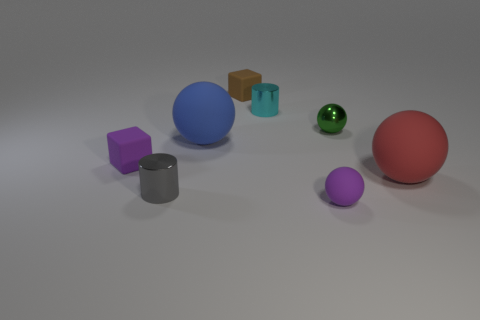Subtract all gray spheres. Subtract all brown cylinders. How many spheres are left? 4 Add 2 tiny green balls. How many objects exist? 10 Subtract all cubes. How many objects are left? 6 Subtract all red objects. Subtract all green shiny objects. How many objects are left? 6 Add 8 big rubber things. How many big rubber things are left? 10 Add 7 blue things. How many blue things exist? 8 Subtract 0 purple cylinders. How many objects are left? 8 